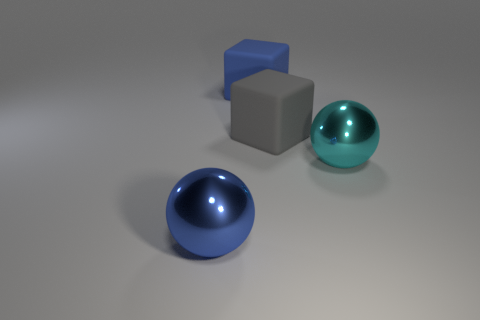Are the blue block and the big cyan ball made of the same material?
Your answer should be very brief. No. What number of gray objects are the same size as the blue shiny thing?
Your response must be concise. 1. Is the number of gray matte objects that are on the left side of the blue rubber thing the same as the number of large objects?
Provide a short and direct response. No. What number of large spheres are both right of the blue metal object and left of the cyan ball?
Provide a short and direct response. 0. Do the blue matte object on the right side of the big blue metal object and the gray rubber object have the same shape?
Offer a very short reply. Yes. There is a gray block that is the same size as the cyan shiny ball; what material is it?
Make the answer very short. Rubber. Are there an equal number of big shiny things that are to the left of the large gray cube and large blue spheres that are behind the blue block?
Your answer should be very brief. No. How many blue balls are in front of the large ball that is on the right side of the big blue thing that is behind the blue sphere?
Offer a very short reply. 1. There is a blue block that is made of the same material as the large gray block; what size is it?
Your response must be concise. Large. Are there more big gray rubber blocks behind the cyan ball than cyan metal things?
Make the answer very short. No. 